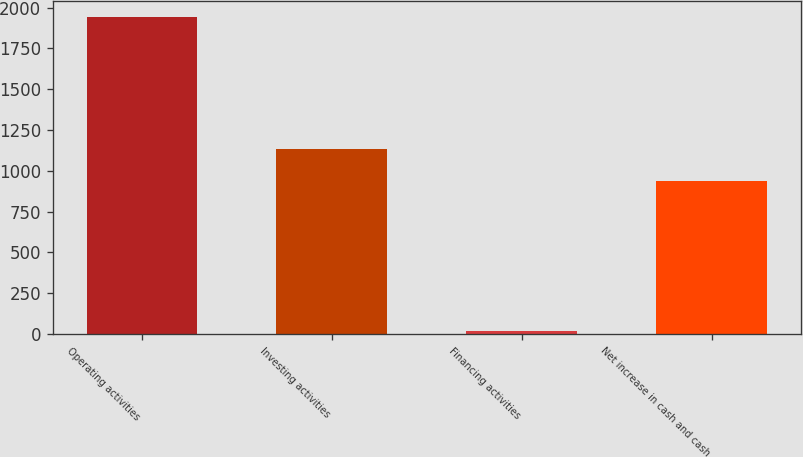<chart> <loc_0><loc_0><loc_500><loc_500><bar_chart><fcel>Operating activities<fcel>Investing activities<fcel>Financing activities<fcel>Net increase in cash and cash<nl><fcel>1942<fcel>1132.6<fcel>16<fcel>940<nl></chart> 